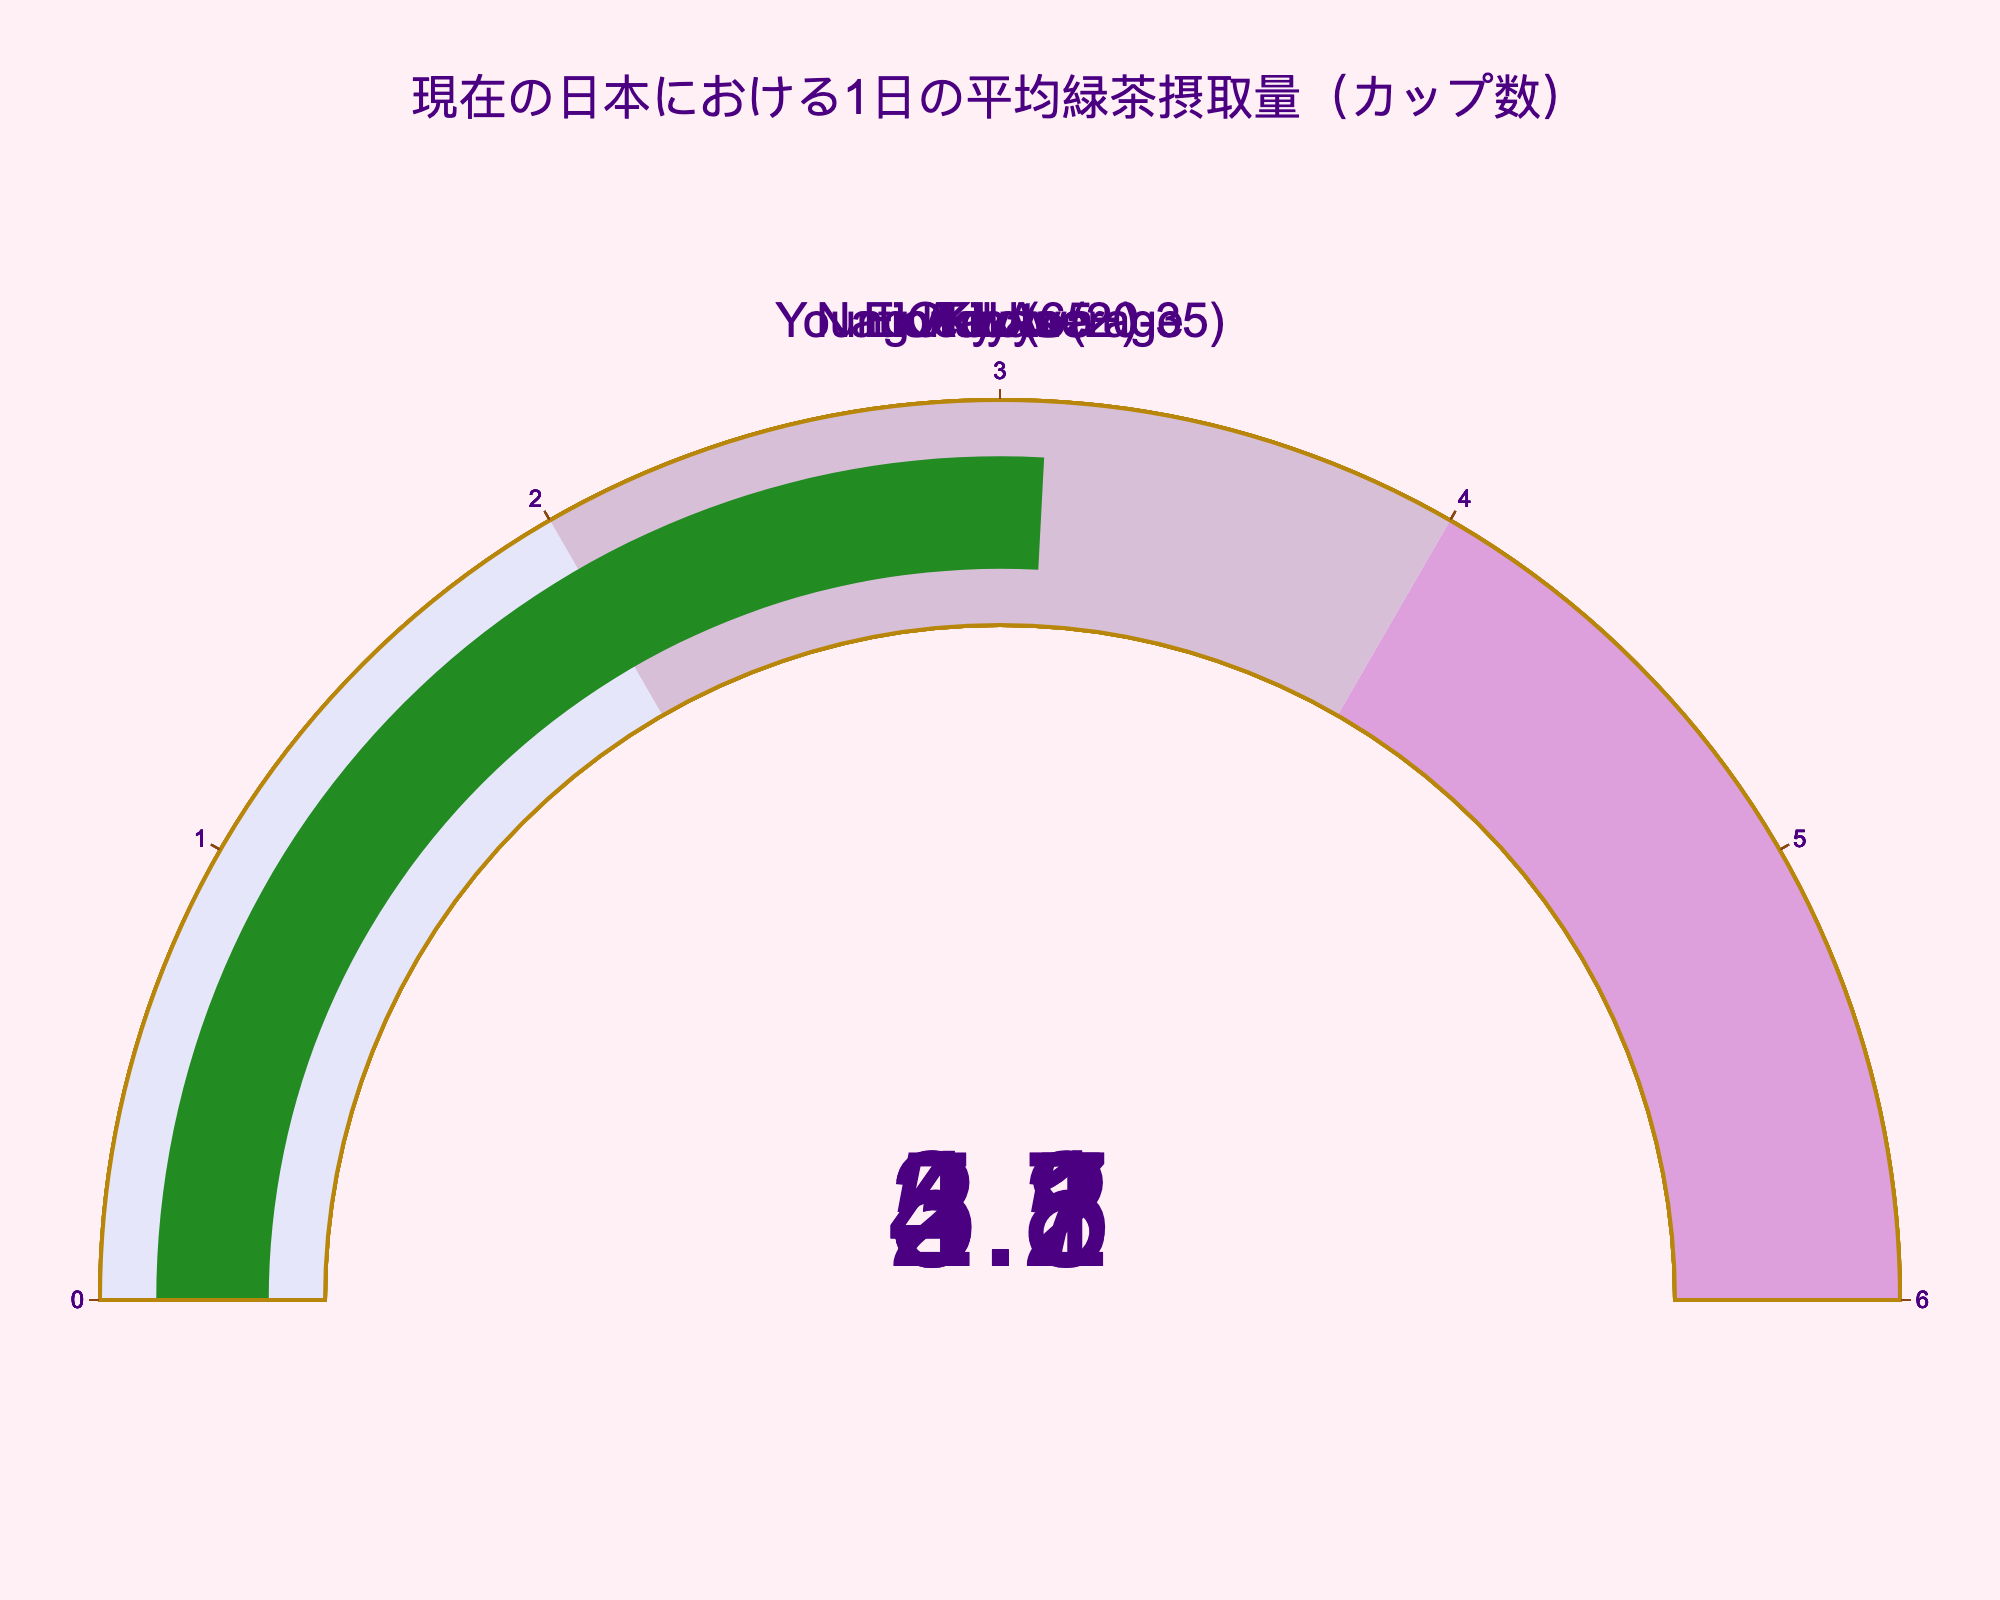What's the title of the figure? The title is located at the top of the gauge chart and serves as a quick summary of what the figure represents.
Answer: 現在の日本における1日の平均緑茶摂取量（カップ数） What's the value of green tea intake in Kyoto? The value for Kyoto is shown on the gauge specifically labeled "Kyoto" within the figure.
Answer: 5.1 Among the listed categories, which has the highest average daily intake of green tea? By comparing the values on each gauge, the highest average daily intake is identified. Kyoto has 5.1 cups, which is the highest among all categories.
Answer: Kyoto How does the green tea intake in Tokyo compare to Okinawa? The value for Tokyo is 4.2 cups, whereas Okinawa's value is 2.8 cups. Hence, Tokyo has a higher intake.
Answer: Tokyo's intake (4.2) is higher than Okinawa's (2.8) What is the combined average daily intake of green tea between the Elderly and Young Adults? The value for Elderly is 4.7 cups and Young Adults is 3.1 cups. The combined value is the sum of these two values. 4.7 + 3.1 = 7.8
Answer: 7.8 cups Which category shows the lowest daily average green tea consumption, and what is the value? By inspecting the gauges, the one with the lowest value is identified. The value for Okinawa is 2.8 cups, which is the lowest.
Answer: Okinawa, 2.8 cups What is the average daily intake of green tea across all categories listed in the figure? Sum the values: 3.5 (National Average) + 4.2 (Tokyo) + 5.1 (Kyoto) + 2.8 (Okinawa) + 4.7 (Elderly) + 3.1 (Young Adults) = 23.4. Divide by the number of categories (6). 23.4 / 6 = 3.9
Answer: 3.9 cups Is the green tea intake in Tokyo above or below the national average? The value for Tokyo is 4.2 cups, and the national average is 3.5 cups. Comparing these, Tokyo's intake is above the national average.
Answer: Above What's the difference between the highest and the lowest green tea intake values among all categories? Identify the highest value (Kyoto, 5.1 cups) and the lowest value (Okinawa, 2.8 cups). Subtract the lowest from the highest. 5.1 - 2.8 = 2.3
Answer: 2.3 cups 